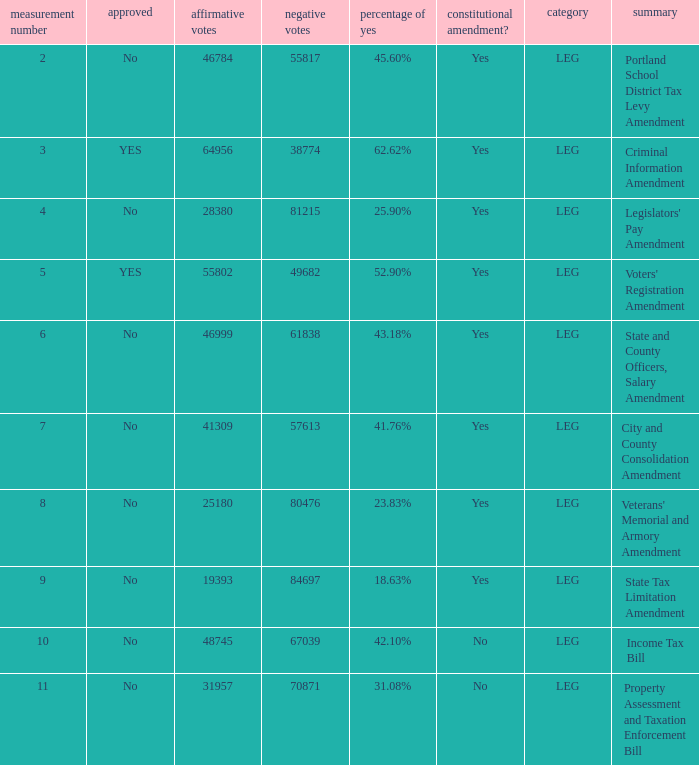Who had 41.76% yes votes City and County Consolidation Amendment. 